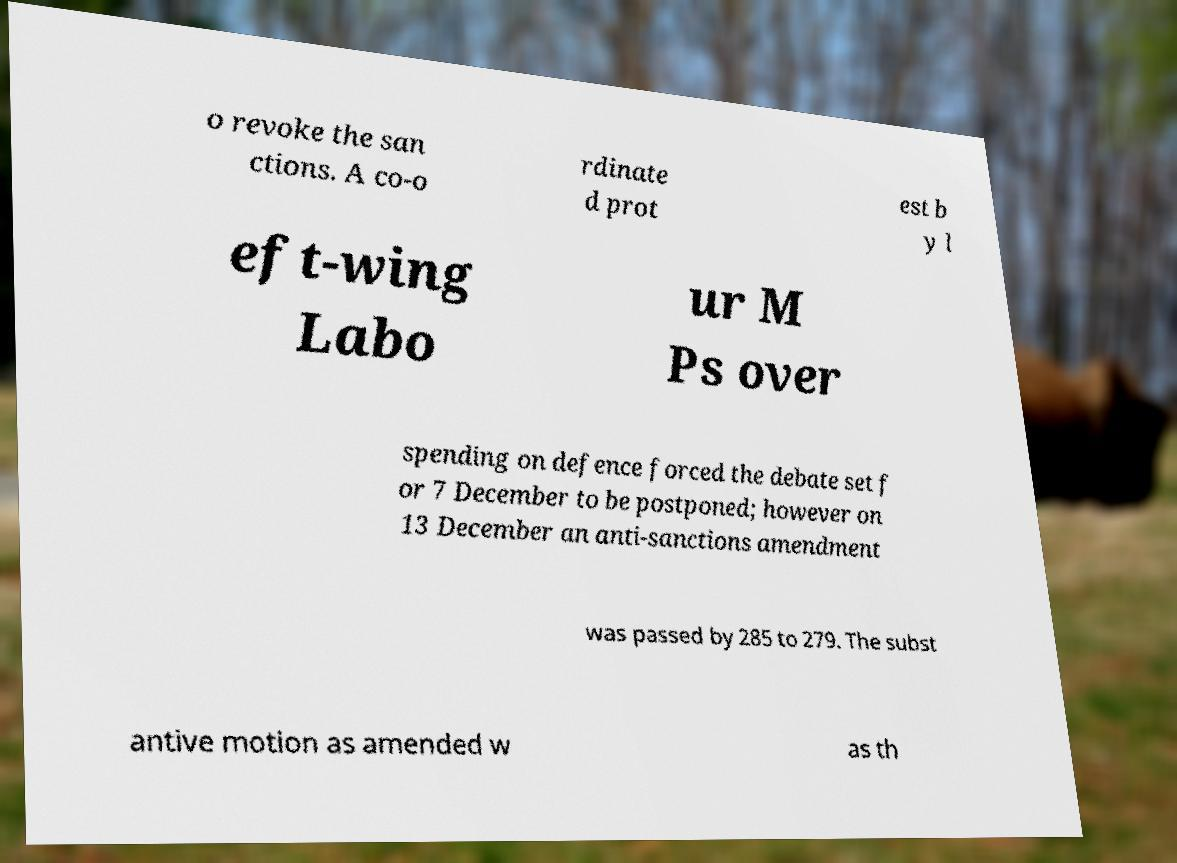There's text embedded in this image that I need extracted. Can you transcribe it verbatim? o revoke the san ctions. A co-o rdinate d prot est b y l eft-wing Labo ur M Ps over spending on defence forced the debate set f or 7 December to be postponed; however on 13 December an anti-sanctions amendment was passed by 285 to 279. The subst antive motion as amended w as th 